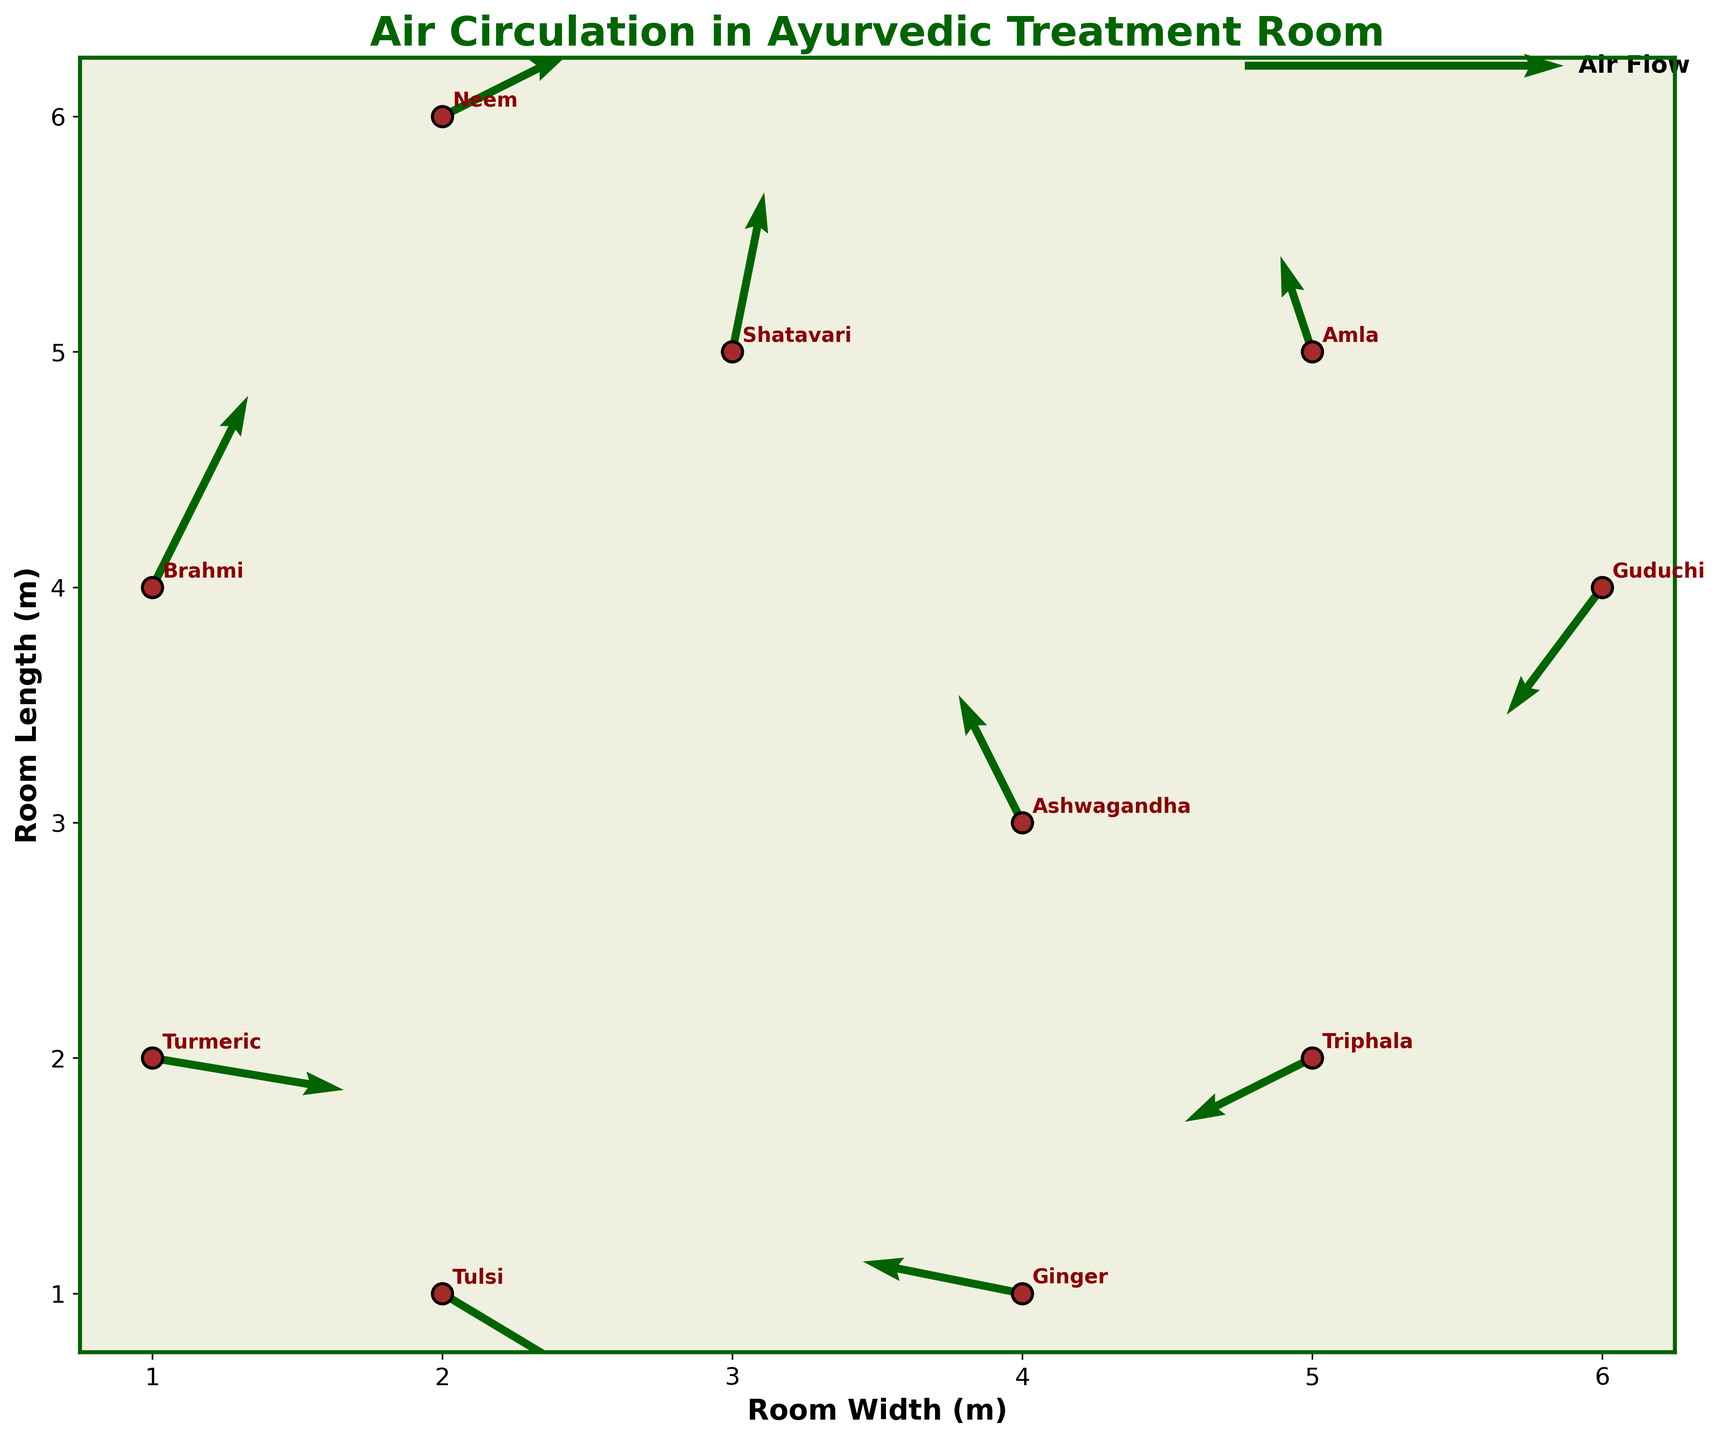What is the title of the quiver plot? The title is typically located at the top of the plot and written in large or bold font. In this case, it reads 'Air Circulation in Ayurvedic Treatment Room'.
Answer: Air Circulation in Ayurvedic Treatment Room How many herbs are being represented in the plot? By looking at the scatter points and labels on the plot, we can count the number of unique herbs. Each scatter point corresponds to one herb, and there are 10 different labels.
Answer: 10 Which herb in the top-right corner of the plot has the largest air flow vector? In the top-right region, check the scatter points and vectors. The herb Neem is located at (2, 6), and its vector (0.4, 0.2) has the largest magnitude in that region.
Answer: Neem What are the coordinates of the herb with the largest negative u-component of air flow? To find this, look for the vector with the most negative u-component. Ginger has a vector (-0.5, 0.1) at coordinates (4, 1).
Answer: (4, 1) Does the air circulation vector for Ashwagandha point primarily upwards or downwards? Investigate the vector direction for Ashwagandha. Its vector (-0.2, 0.4) has a positive v-component, indicating it primarily points upwards.
Answer: Upwards Which herb has the smallest air flow vector in terms of magnitude? Calculate the magnitude of each vector (u, v). For example, the magnitude of Amla's vector (-0.1, 0.3) is sqrt((-0.1)^2 + (0.3)^2) = 0.316, which is the smallest.
Answer: Amla Compare the air flow directions for Tulsi and Triphala. Are they pointing in the same general direction? Tulsi's vector is (0.5, -0.3) and Triphala's vector is (-0.4, -0.2). Tulsi's vector points to the right and slightly downwards, while Triphala's vector points to the left and downwards, so they are not in the same general direction.
Answer: No What is the average length of the room considering the y-axis coordinates of the scatter points? The y-coordinates range from 1 to 6. The average y-coordinate is (1+4+6+2+5) / 5 = 3.6, considering median herbs' mind-scaled room length.
Answer: 3.6 